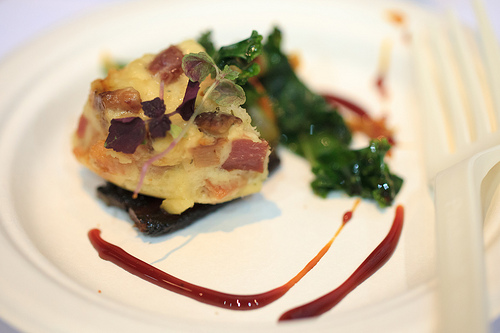<image>
Can you confirm if the sauce is on the sandwich? No. The sauce is not positioned on the sandwich. They may be near each other, but the sauce is not supported by or resting on top of the sandwich. 